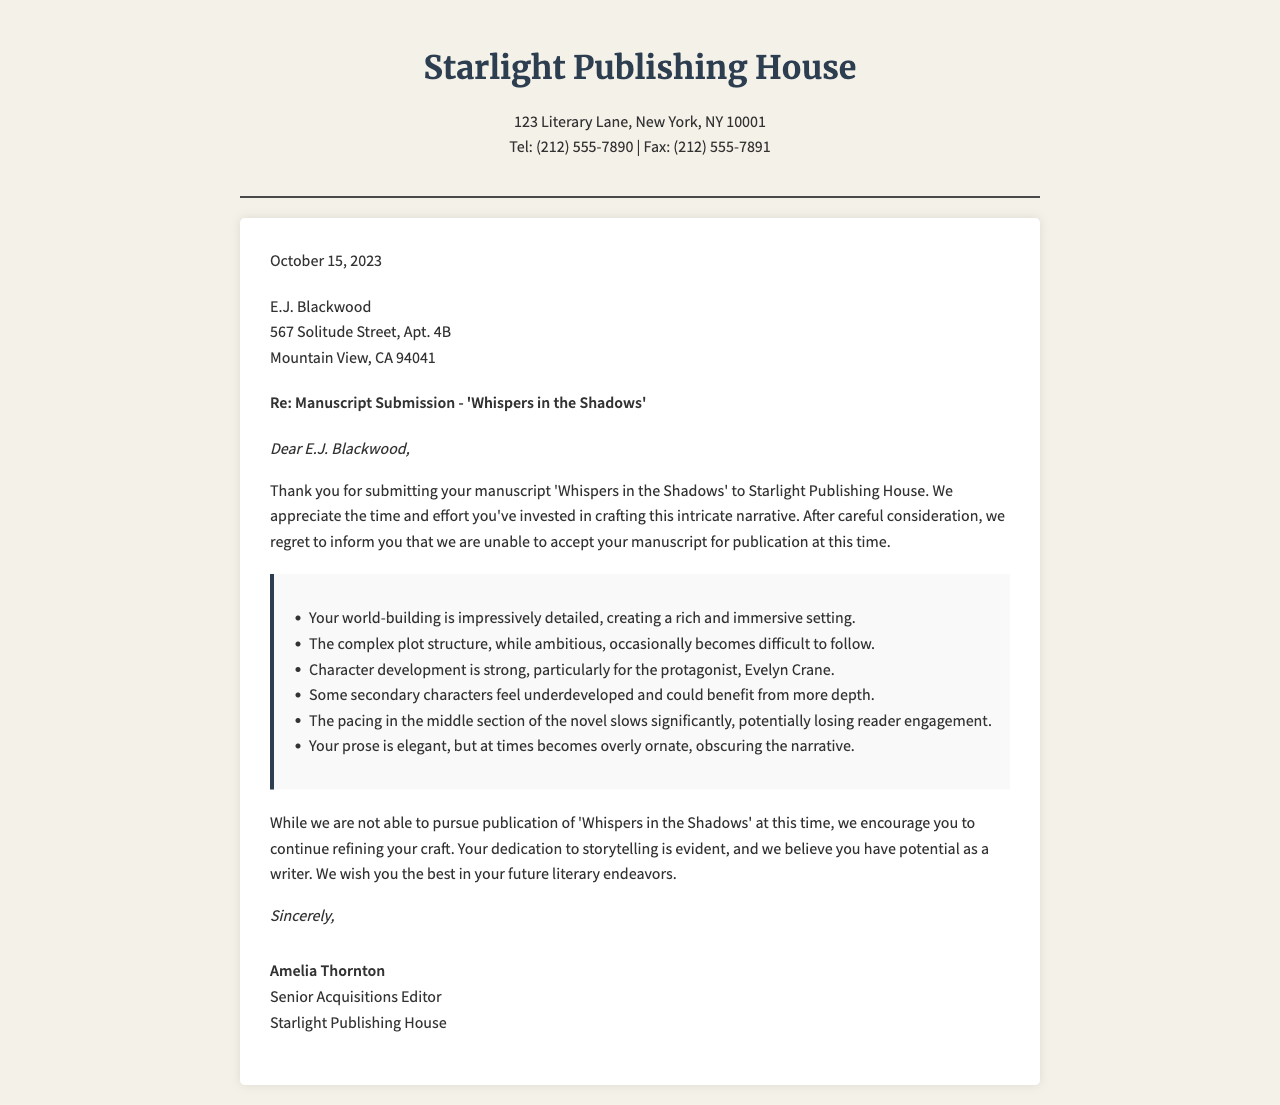What is the name of the publishing house? The name of the publishing house can be found in the header of the document, which states "Starlight Publishing House."
Answer: Starlight Publishing House What is the date of the letter? The date is given in the letter, which states "October 15, 2023."
Answer: October 15, 2023 Who is the recipient of the letter? The recipient's name is clearly mentioned at the beginning of the letter as "E.J. Blackwood."
Answer: E.J. Blackwood What is the title of the submitted manuscript? The title of the manuscript is mentioned in the subject line of the letter as "'Whispers in the Shadows'."
Answer: 'Whispers in the Shadows' How many feedback points are listed in the letter? The feedback section is presented as a bulleted list, containing six distinct points of feedback.
Answer: Six Which character is highlighted for strong development? The feedback mentions "Evelyn Crane" as the protagonist with strong development.
Answer: Evelyn Crane What issue is mentioned regarding secondary characters? The feedback notes that "some secondary characters feel underdeveloped."
Answer: Underdeveloped Who signed the letter? The signature at the end of the letter is "Amelia Thornton."
Answer: Amelia Thornton What aspect of the prose is critiqued? The feedback indicates that the prose can be "overly ornate, obscuring the narrative."
Answer: Overly ornate 